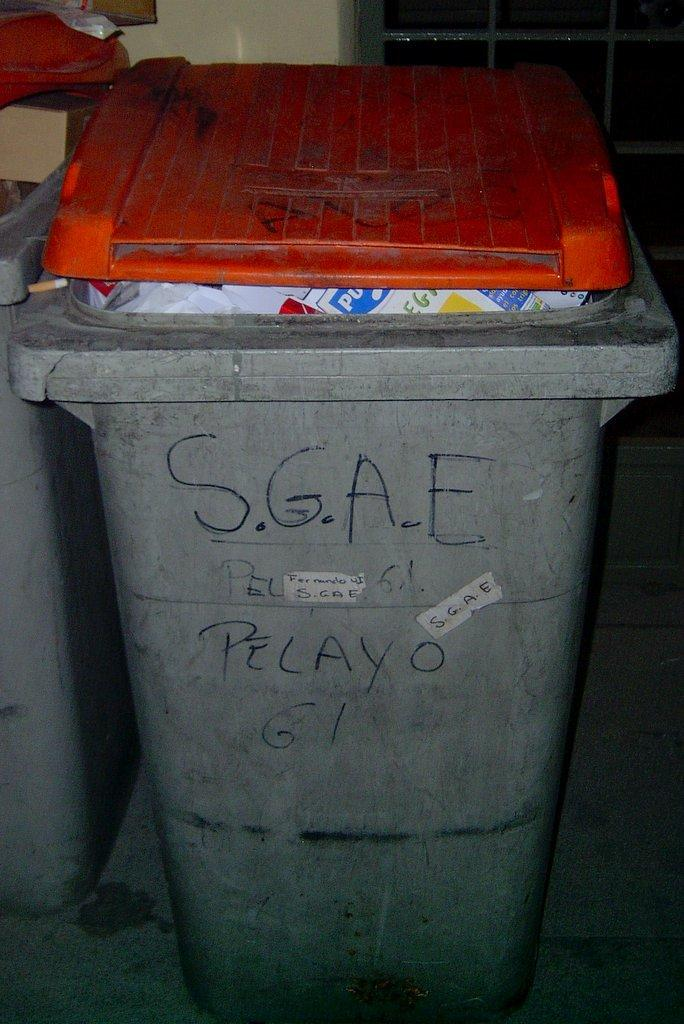Provide a one-sentence caption for the provided image. A grey container with an orange lid has black writing of S.G.A.E. 